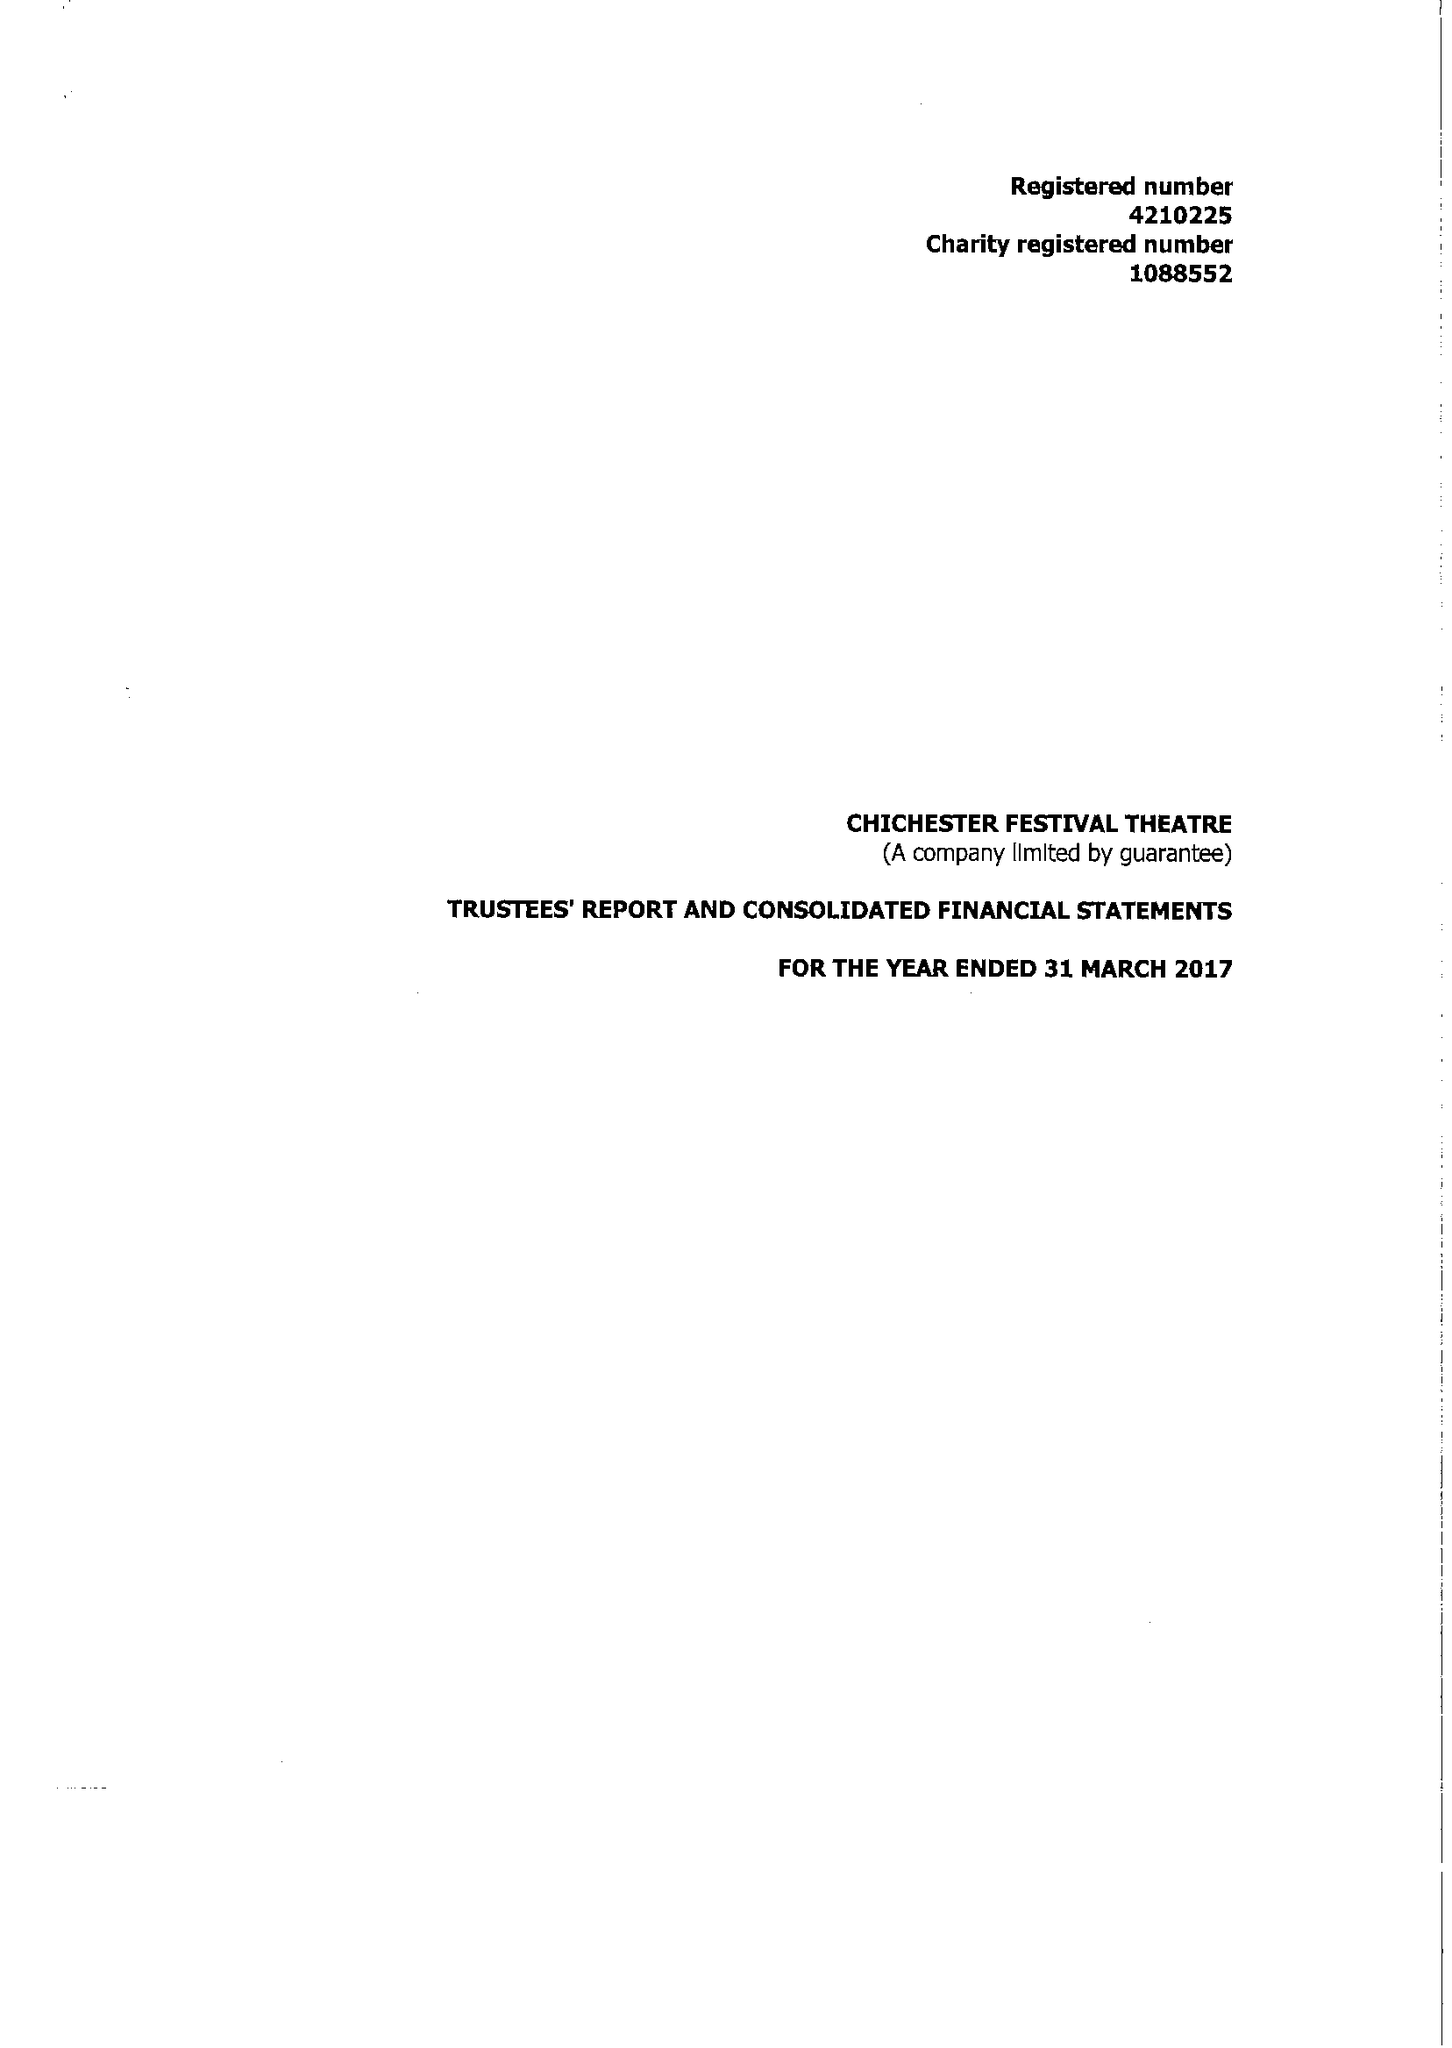What is the value for the address__post_town?
Answer the question using a single word or phrase. CHICHESTER 